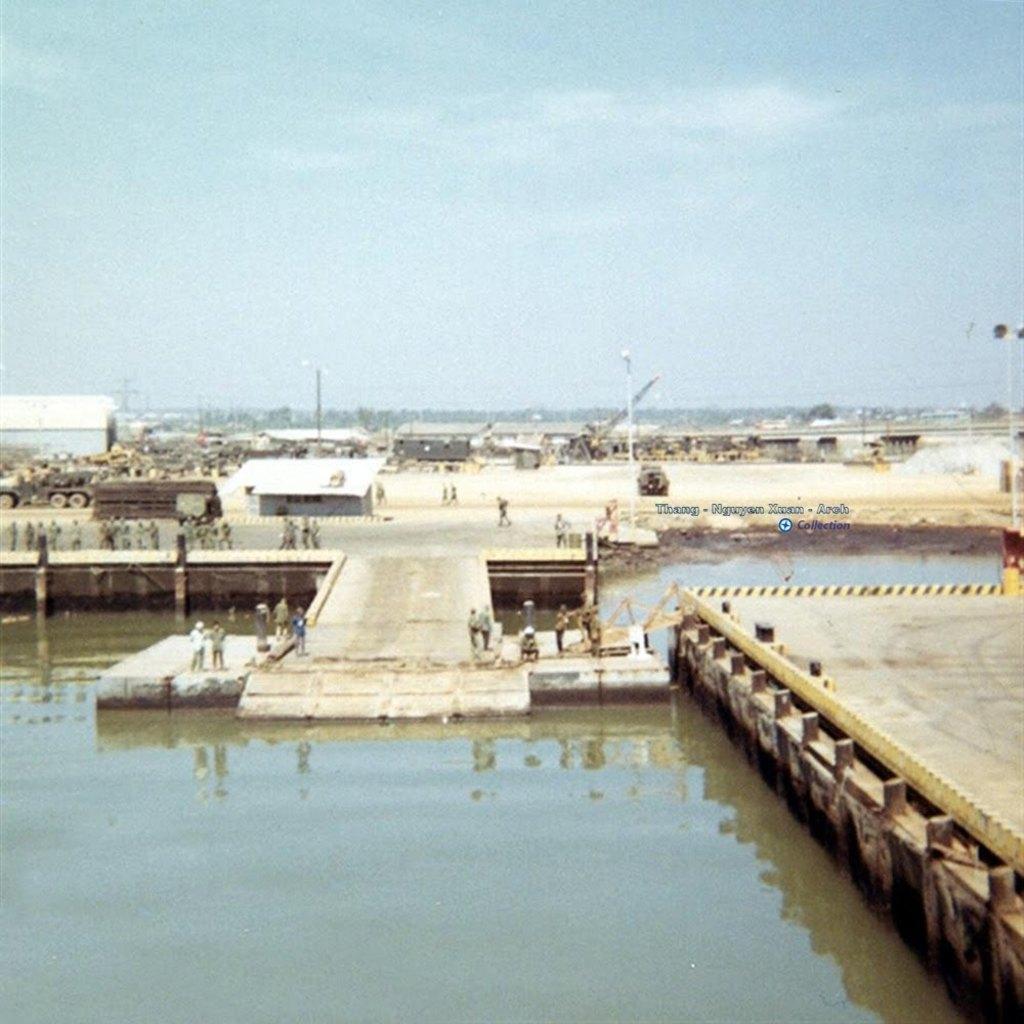How would you summarize this image in a sentence or two? This is an outside view. At the bottom, I can see the water. On the right side there is a wooden plank and also there is a railing. On the left side there are few people standing on the road. In the background there are few buildings, vehicles and light poles. At the top of the image I can see the sky. 